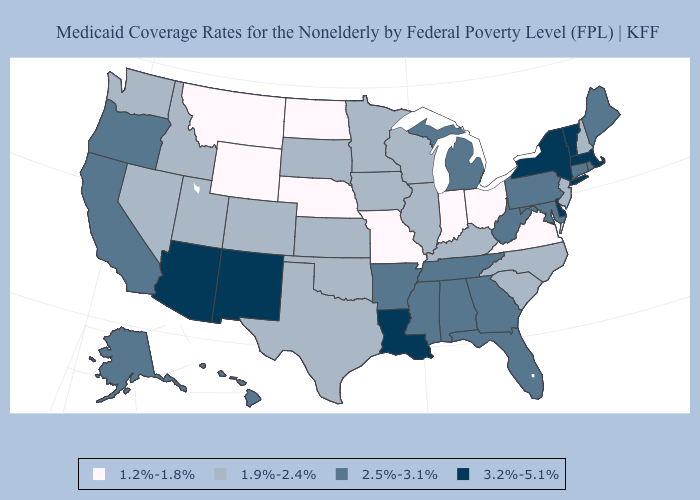Name the states that have a value in the range 1.2%-1.8%?
Keep it brief. Indiana, Missouri, Montana, Nebraska, North Dakota, Ohio, Virginia, Wyoming. What is the lowest value in states that border Wyoming?
Keep it brief. 1.2%-1.8%. Name the states that have a value in the range 1.9%-2.4%?
Quick response, please. Colorado, Idaho, Illinois, Iowa, Kansas, Kentucky, Minnesota, Nevada, New Hampshire, New Jersey, North Carolina, Oklahoma, South Carolina, South Dakota, Texas, Utah, Washington, Wisconsin. What is the lowest value in the South?
Give a very brief answer. 1.2%-1.8%. What is the highest value in the Northeast ?
Short answer required. 3.2%-5.1%. Among the states that border Oregon , does Nevada have the lowest value?
Quick response, please. Yes. What is the highest value in states that border Oklahoma?
Concise answer only. 3.2%-5.1%. Which states hav the highest value in the South?
Keep it brief. Delaware, Louisiana. Name the states that have a value in the range 3.2%-5.1%?
Keep it brief. Arizona, Delaware, Louisiana, Massachusetts, New Mexico, New York, Vermont. What is the value of California?
Write a very short answer. 2.5%-3.1%. Name the states that have a value in the range 1.9%-2.4%?
Give a very brief answer. Colorado, Idaho, Illinois, Iowa, Kansas, Kentucky, Minnesota, Nevada, New Hampshire, New Jersey, North Carolina, Oklahoma, South Carolina, South Dakota, Texas, Utah, Washington, Wisconsin. What is the lowest value in states that border Arizona?
Be succinct. 1.9%-2.4%. Which states have the lowest value in the Northeast?
Give a very brief answer. New Hampshire, New Jersey. Name the states that have a value in the range 1.2%-1.8%?
Give a very brief answer. Indiana, Missouri, Montana, Nebraska, North Dakota, Ohio, Virginia, Wyoming. What is the highest value in states that border Minnesota?
Concise answer only. 1.9%-2.4%. 